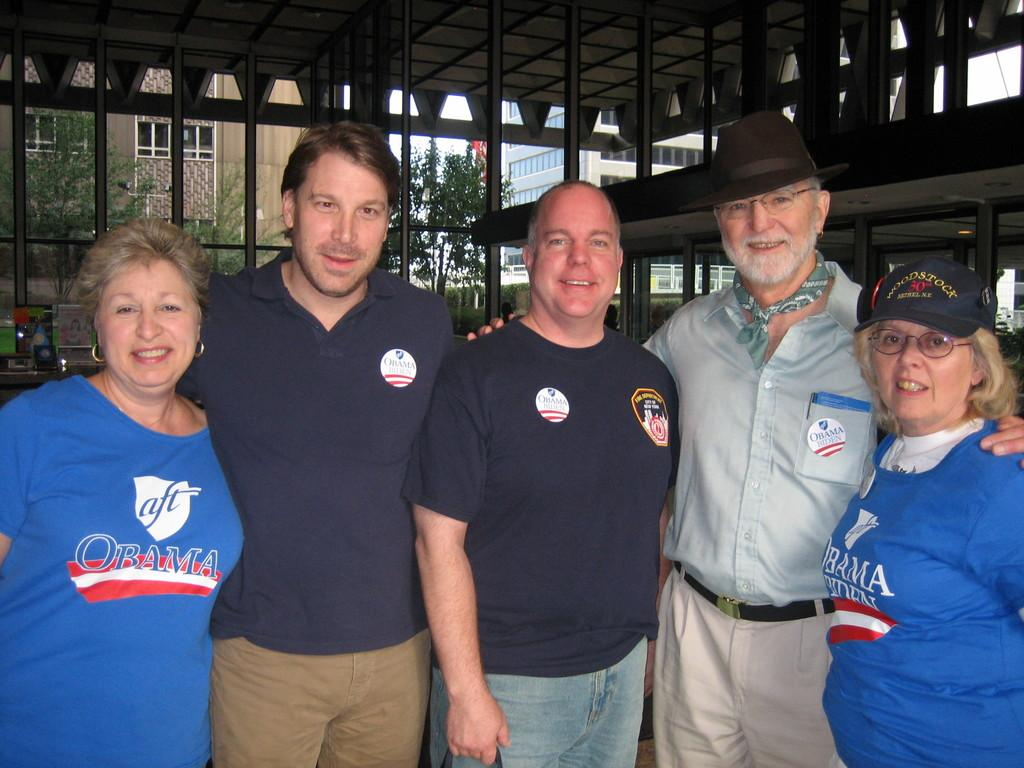What can be seen in the image involving people? There are people standing in the image. What type of structure is visible in the image? There is a shed visible in the image. What else is present in the image besides people and the shed? There are objects present in the image. What can be seen in the distance in the image? There are buildings and trees in the background of the image. What type of drink is being served at the shed in the image? There is no drink or serving activity present in the image. 